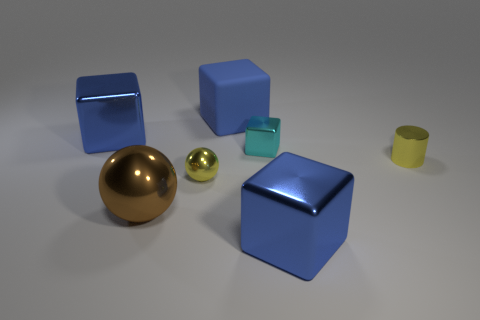There is a small metal object that is in front of the yellow cylinder; does it have the same shape as the big thing right of the large blue rubber block?
Ensure brevity in your answer.  No. The brown metal object that is the same size as the matte cube is what shape?
Provide a short and direct response. Sphere. Are there an equal number of matte things in front of the yellow metal cylinder and big objects that are behind the tiny cyan metal thing?
Ensure brevity in your answer.  No. Are there any other things that have the same shape as the large brown thing?
Your answer should be compact. Yes. Is the blue object that is to the left of the brown thing made of the same material as the brown ball?
Ensure brevity in your answer.  Yes. There is a cylinder that is the same size as the cyan object; what material is it?
Ensure brevity in your answer.  Metal. How many other objects are there of the same material as the big brown object?
Offer a very short reply. 5. There is a cyan shiny cube; is it the same size as the yellow metallic thing to the left of the tiny cylinder?
Keep it short and to the point. Yes. Are there fewer small yellow metallic objects that are right of the cyan shiny block than small yellow shiny balls that are left of the brown metal thing?
Your answer should be very brief. No. What size is the shiny block that is in front of the small shiny block?
Your response must be concise. Large. 